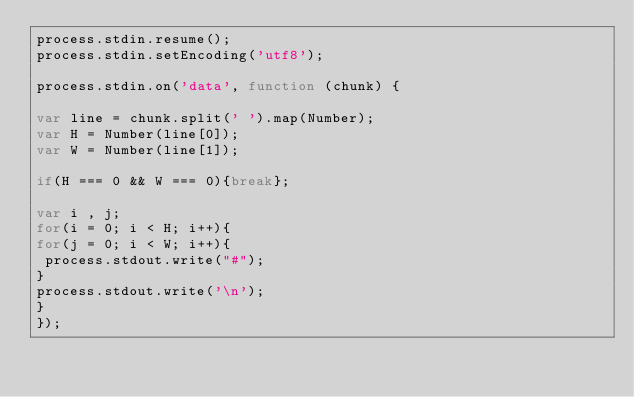Convert code to text. <code><loc_0><loc_0><loc_500><loc_500><_JavaScript_>process.stdin.resume();
process.stdin.setEncoding('utf8');

process.stdin.on('data', function (chunk) {

var line = chunk.split(' ').map(Number);
var H = Number(line[0]);
var W = Number(line[1]);

if(H === 0 && W === 0){break};

var i , j;
for(i = 0; i < H; i++){
for(j = 0; i < W; i++){
 process.stdout.write("#");
}
process.stdout.write('\n');
}
});</code> 